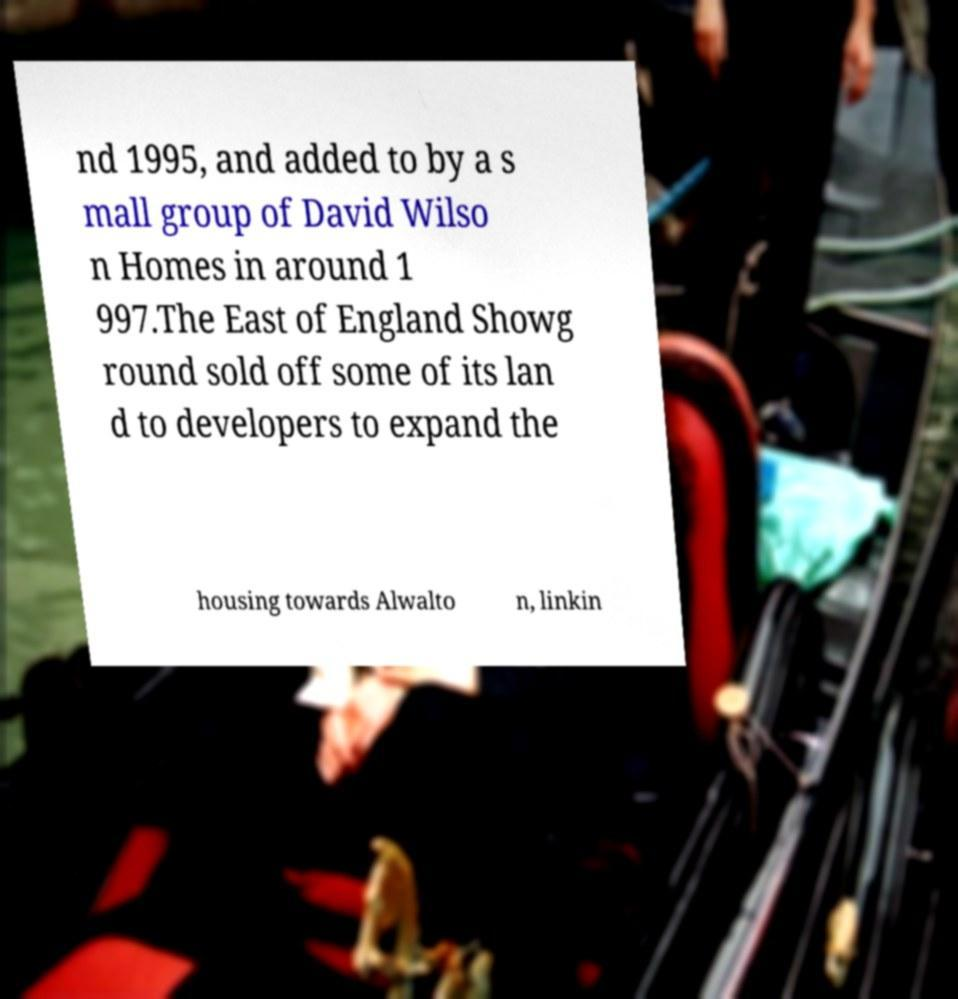There's text embedded in this image that I need extracted. Can you transcribe it verbatim? nd 1995, and added to by a s mall group of David Wilso n Homes in around 1 997.The East of England Showg round sold off some of its lan d to developers to expand the housing towards Alwalto n, linkin 